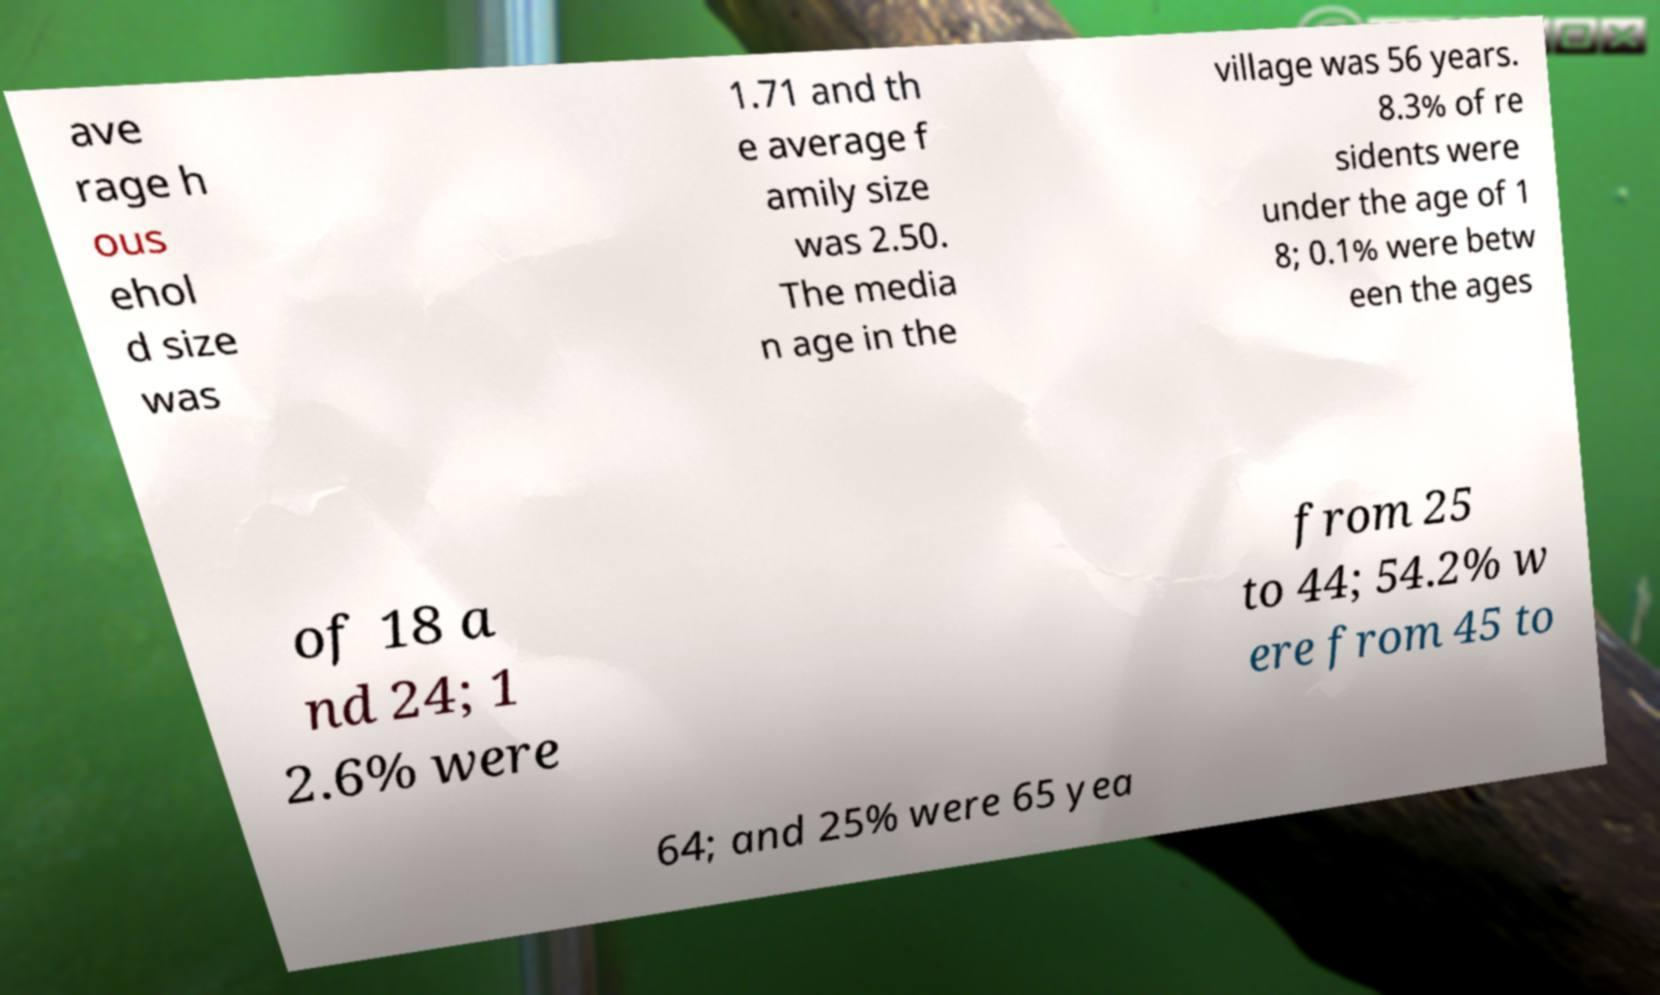There's text embedded in this image that I need extracted. Can you transcribe it verbatim? ave rage h ous ehol d size was 1.71 and th e average f amily size was 2.50. The media n age in the village was 56 years. 8.3% of re sidents were under the age of 1 8; 0.1% were betw een the ages of 18 a nd 24; 1 2.6% were from 25 to 44; 54.2% w ere from 45 to 64; and 25% were 65 yea 